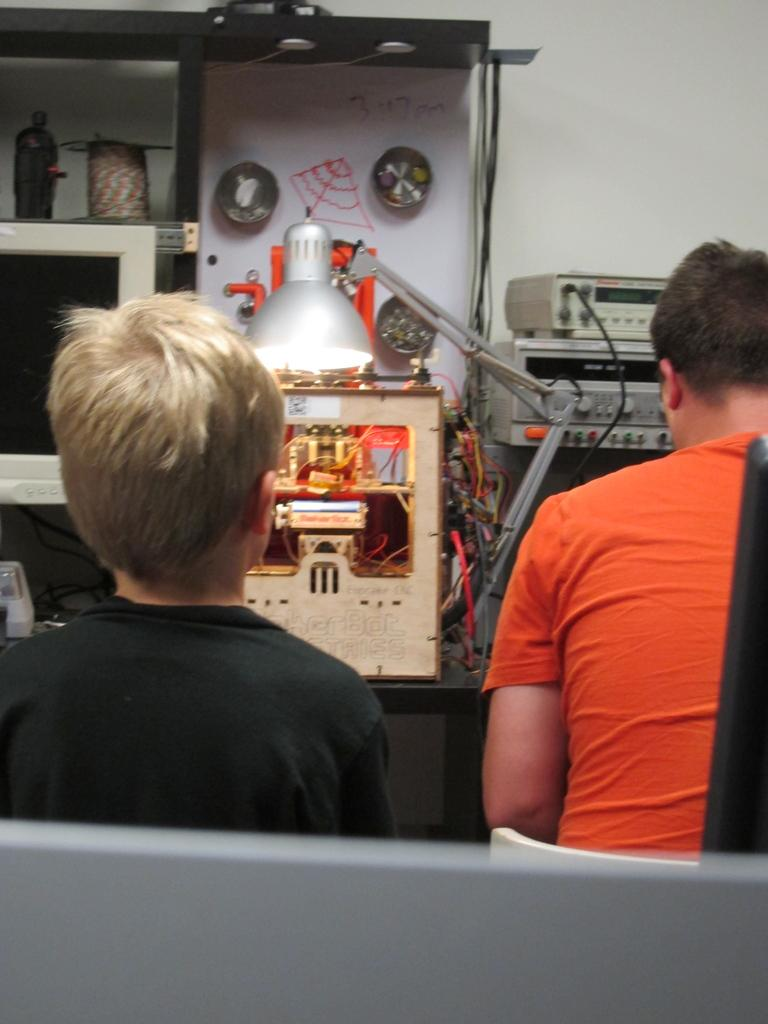What are the people in the image doing? The people in the image are sitting on chairs. What can be seen in the background of the image? There are objects in the background of the image. What is the paper used for in the image? The paper is visible in the image, but its purpose is not clear. What type of equipment is present in the image? There are machines in the image. What is used to hold or store items in the image? There is a rack in the image. What is the main structure in the image? There is a wall in the image. What type of food is being prepared on the shelf in the image? There is no shelf or food preparation visible in the image. 